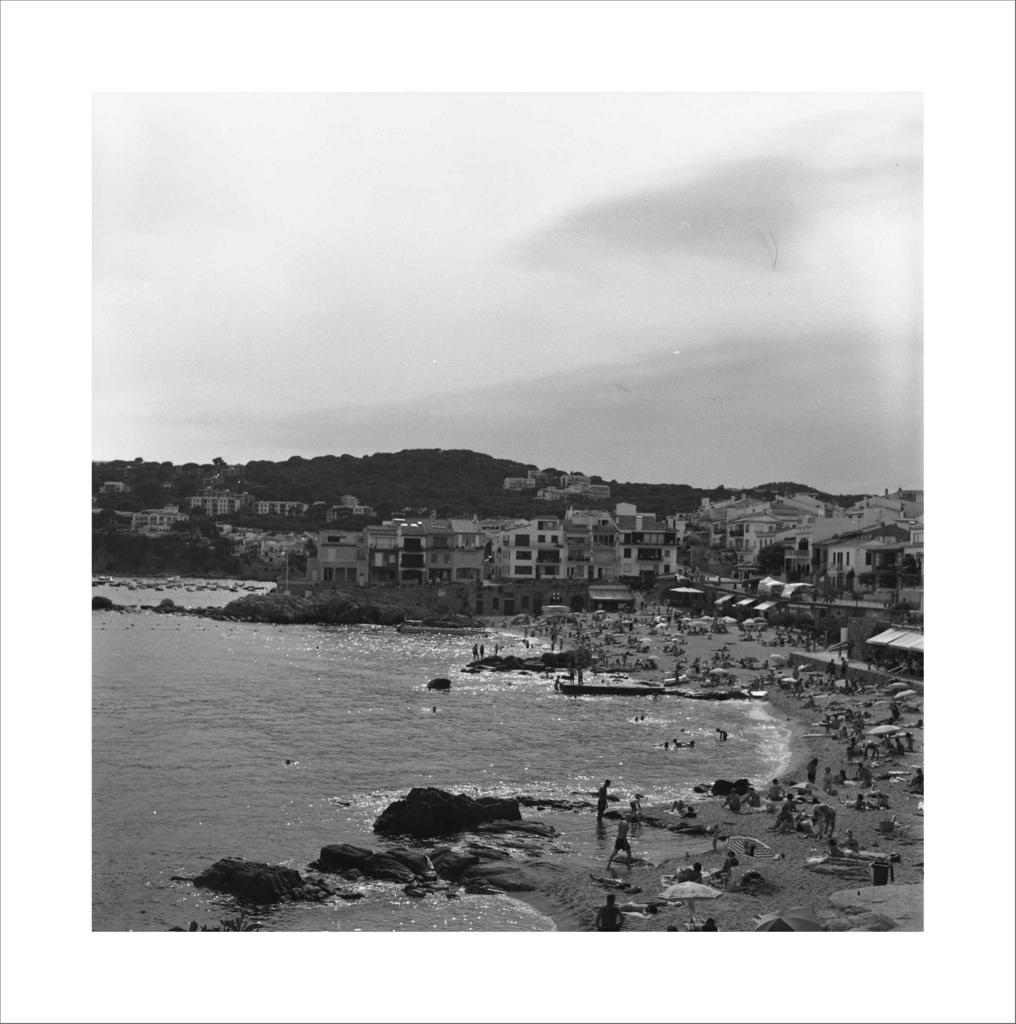What is the color scheme of the image? The image is black and white. Where are the people in the image located? The people are on the beach. What natural features can be seen in the image? There are rocks, water, hills, and the sky with clouds visible in the image. What type of structures are present in the image? There are houses in the image. What type of vest is the person wearing on the beach in the image? There is no vest visible on any person in the image, as it is black and white and does not show clothing details. What experience can be gained from the image? The image itself does not provide an experience, but it may evoke feelings or memories related to the beach or the black and white color scheme. 